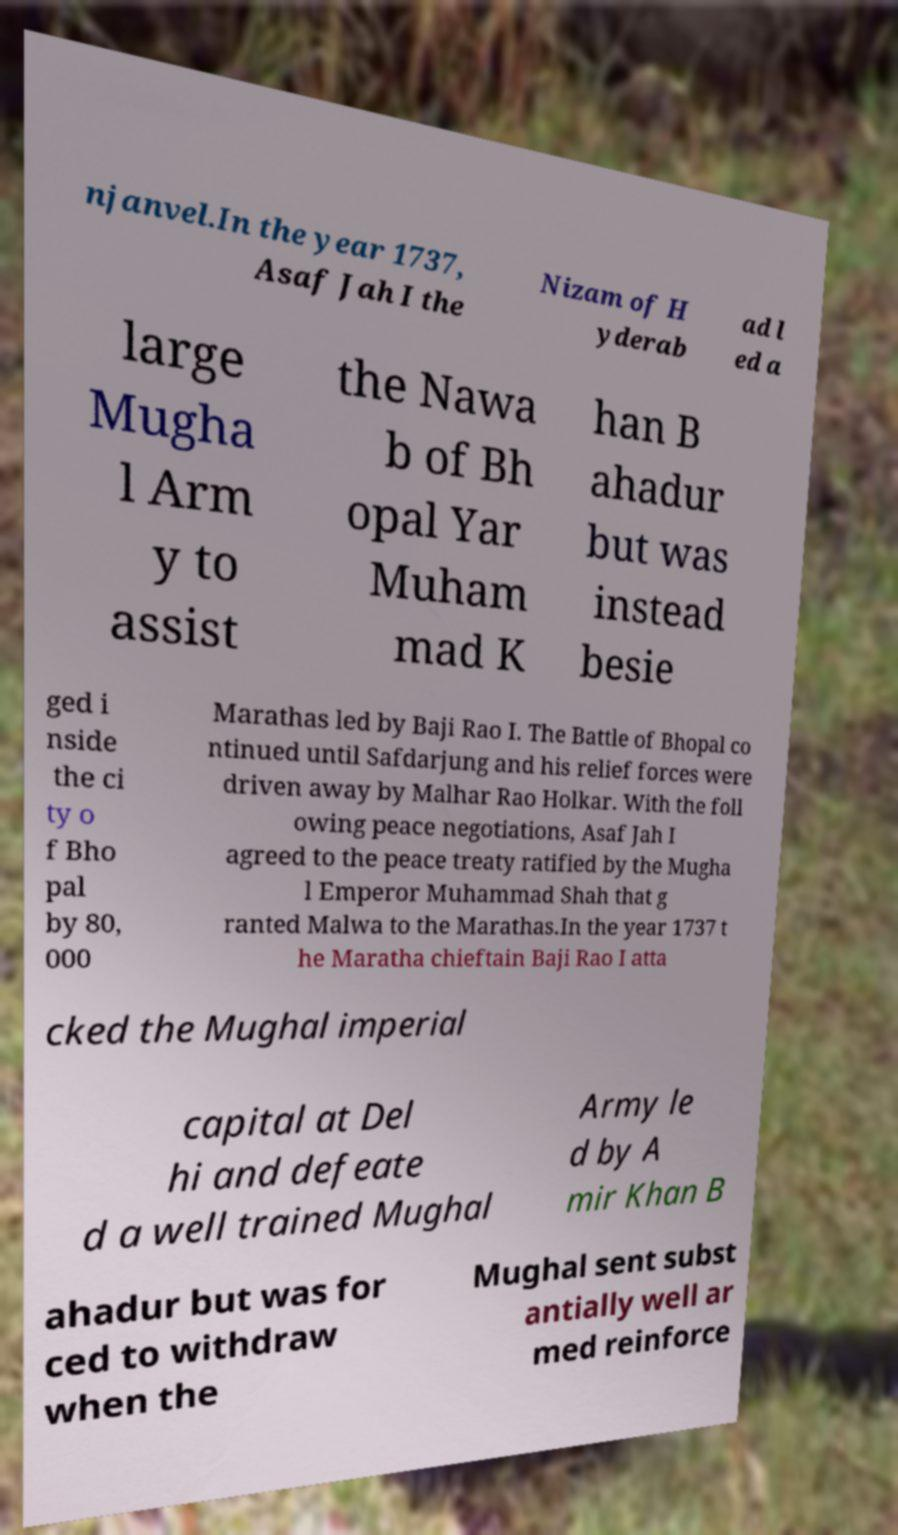Can you read and provide the text displayed in the image?This photo seems to have some interesting text. Can you extract and type it out for me? njanvel.In the year 1737, Asaf Jah I the Nizam of H yderab ad l ed a large Mugha l Arm y to assist the Nawa b of Bh opal Yar Muham mad K han B ahadur but was instead besie ged i nside the ci ty o f Bho pal by 80, 000 Marathas led by Baji Rao I. The Battle of Bhopal co ntinued until Safdarjung and his relief forces were driven away by Malhar Rao Holkar. With the foll owing peace negotiations, Asaf Jah I agreed to the peace treaty ratified by the Mugha l Emperor Muhammad Shah that g ranted Malwa to the Marathas.In the year 1737 t he Maratha chieftain Baji Rao I atta cked the Mughal imperial capital at Del hi and defeate d a well trained Mughal Army le d by A mir Khan B ahadur but was for ced to withdraw when the Mughal sent subst antially well ar med reinforce 